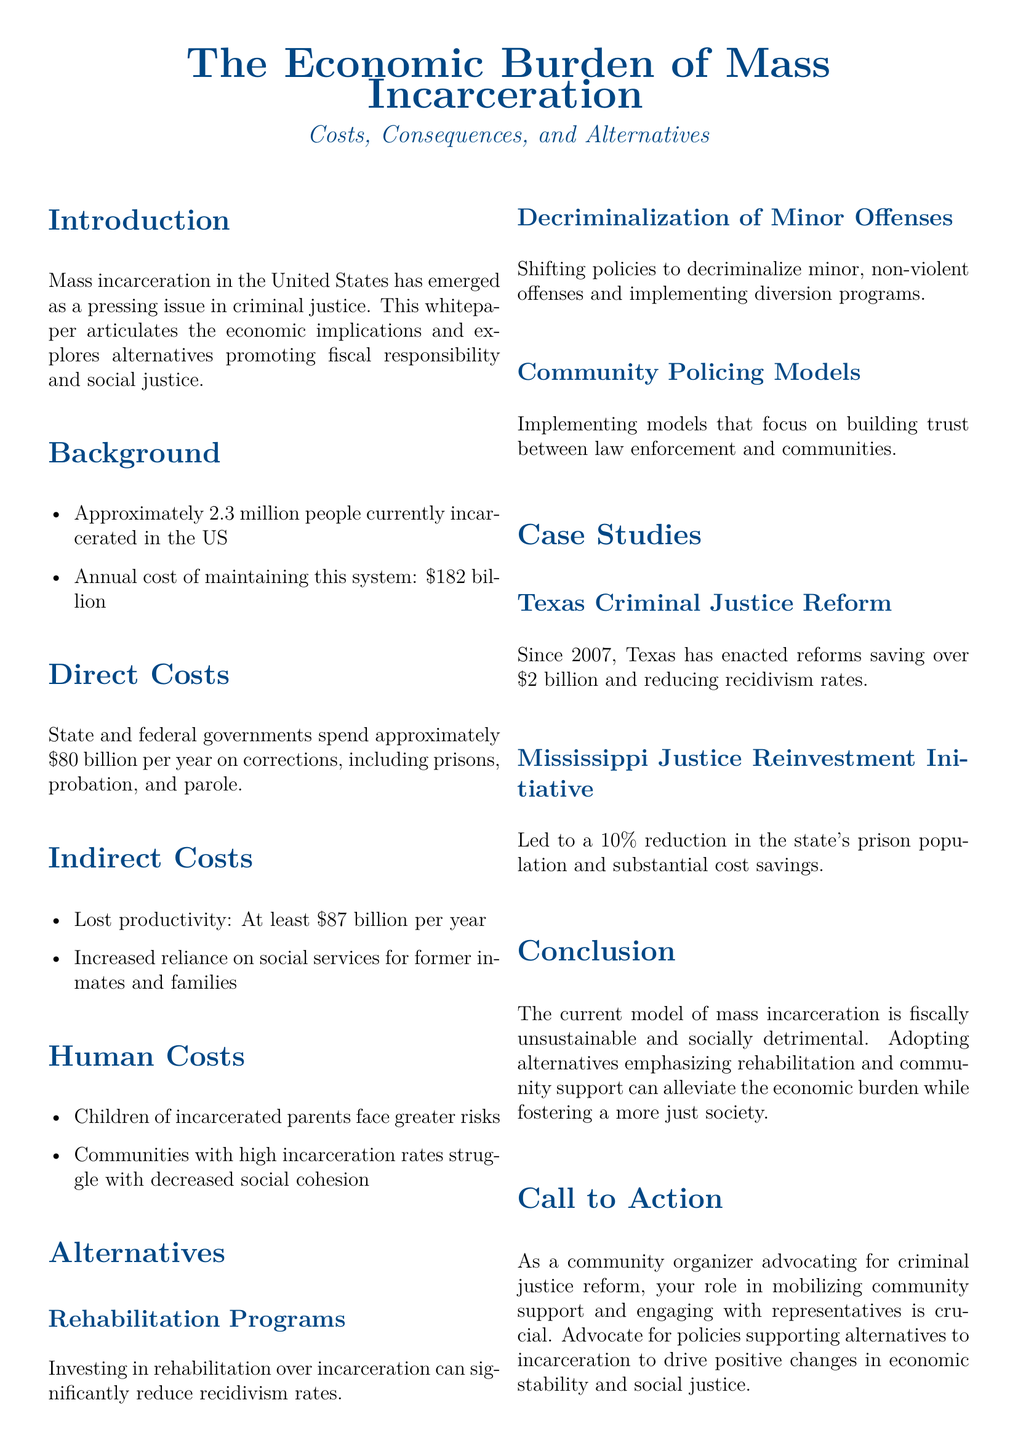What is the current number of people incarcerated in the US? The document states that approximately 2.3 million people are currently incarcerated in the US.
Answer: 2.3 million What is the annual cost of maintaining the mass incarceration system? The document highlights that the annual cost is approximately $182 billion.
Answer: $182 billion What percentage reduction in the prison population did the Mississippi Justice Reinvestment Initiative achieve? The document mentions that this initiative led to a 10% reduction in the state's prison population.
Answer: 10% What has Texas saved since implementing criminal justice reforms in 2007? The document specifies that Texas has saved over $2 billion due to these reforms.
Answer: $2 billion What is one of the human costs associated with mass incarceration mentioned in the document? The document lists that children of incarcerated parents face greater risks as a human cost.
Answer: Greater risks Why is investing in rehabilitation programs suggested in the document? It is suggested because such investments can significantly reduce recidivism rates.
Answer: Reduce recidivism rates What type of models does the document advocate for in policing? The document advocates for community policing models that focus on building trust.
Answer: Community policing models What is the focus of the whitepaper? The focus of the whitepaper is on the economic implications of mass incarceration and exploring alternatives.
Answer: Economic implications and alternatives 